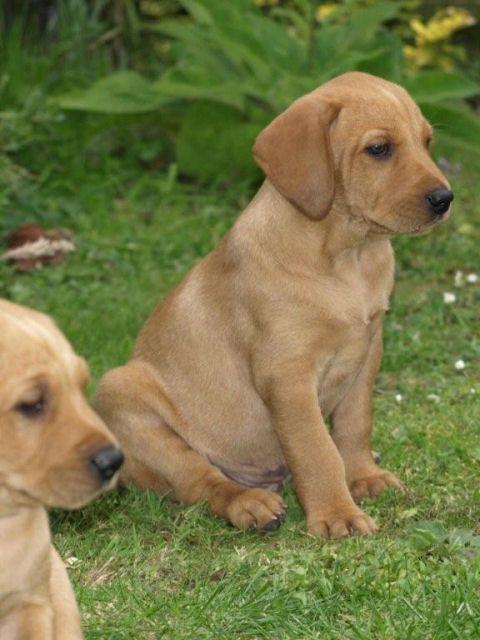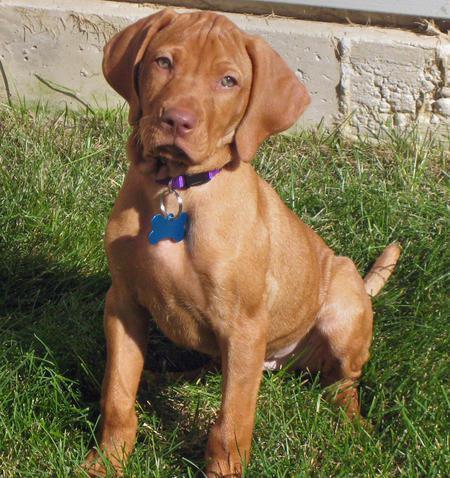The first image is the image on the left, the second image is the image on the right. For the images shown, is this caption "The left image contains at least two dogs." true? Answer yes or no. Yes. The first image is the image on the left, the second image is the image on the right. Examine the images to the left and right. Is the description "The dogs in each of the images are outside." accurate? Answer yes or no. Yes. 